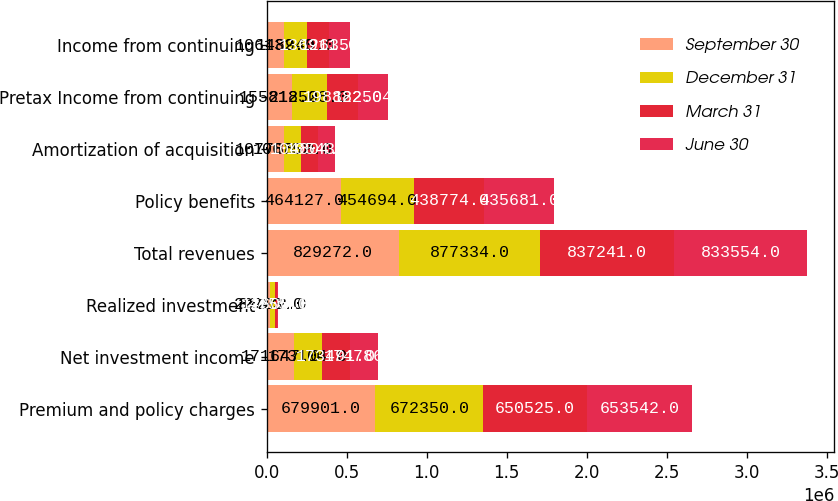Convert chart to OTSL. <chart><loc_0><loc_0><loc_500><loc_500><stacked_bar_chart><ecel><fcel>Premium and policy charges<fcel>Net investment income<fcel>Realized investment<fcel>Total revenues<fcel>Policy benefits<fcel>Amortization of acquisition<fcel>Pretax Income from continuing<fcel>Income from continuing<nl><fcel>September 30<fcel>679901<fcel>171647<fcel>22723<fcel>829272<fcel>464127<fcel>107788<fcel>155812<fcel>106132<nl><fcel>December 31<fcel>672350<fcel>173104<fcel>31272<fcel>877334<fcel>454694<fcel>106752<fcel>218528<fcel>148940<nl><fcel>March 31<fcel>650525<fcel>173491<fcel>12600<fcel>837241<fcel>438774<fcel>104804<fcel>198822<fcel>136911<nl><fcel>June 30<fcel>653542<fcel>174786<fcel>4755<fcel>833554<fcel>435681<fcel>105437<fcel>182504<fcel>126357<nl></chart> 